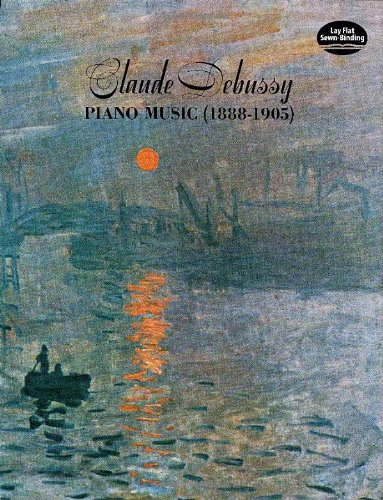Describe the scene depicted on the cover of this book. The cover showcases a serene water scene at dusk or dawn, with subtle shifts of color in the sky and water, enhancing the reflective mood. A solitary figure in a boat adds a calm, introspective quality to the painting. 